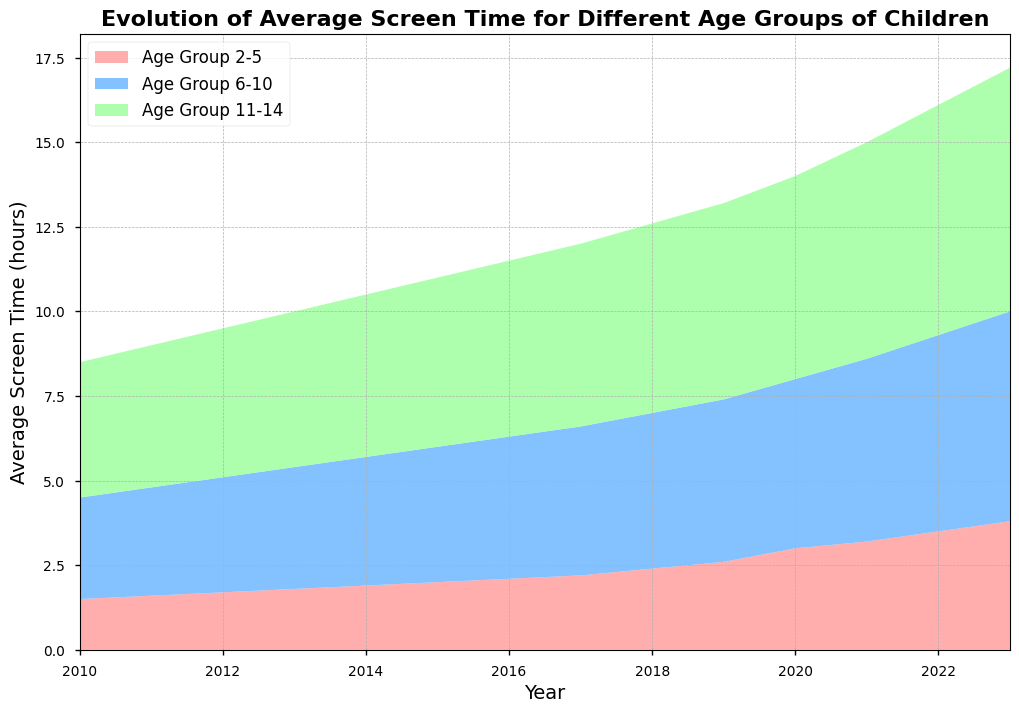What's the trend in average screen time for Age Group 2-5 from 2010 to 2023? By observing the filled area representing Age Group 2-5 over the years, we can see that the screen time generally increases from about 1.5 hours in 2010 to 3.8 hours in 2023.
Answer: Increasing Which age group had the highest average screen time in 2023? By looking at the heights of the stacks in 2023, Age Group 11-14 has the highest average screen time, peaking at 7.2 hours.
Answer: Age Group 11-14 In which year does Age Group 2-5 first exceed 2 hours of average screen time? Checking the plot for when the filled area representing Age Group 2-5 surpasses the 2-hour mark, it first happens in 2015.
Answer: 2015 How much did the average screen time for Age Group 11-14 increase from 2010 to 2023? The average screen time for Age Group 11-14 increased from 4 hours in 2010 to 7.2 hours in 2023. The increase is calculated as 7.2 - 4 = 3.2 hours.
Answer: 3.2 hours Which year shows the most significant increase in average screen time for Age Group 6-10? By comparing the incremental changes between consecutive years, the most significant increase for Age Group 6-10 appears between 2020 (5.0 hours) and 2021 (5.4 hours) with a 0.4-hour increase.
Answer: Between 2020 and 2021 By 2023, what is the total combined average screen time for all age groups? To find the combined average screen time for 2023, sum the values for each age group: 3.8 (Age Group 2-5) + 6.2 (Age Group 6-10) + 7.2 (Age Group 11-14) = 17.2 hours.
Answer: 17.2 hours Which age group has seen the least variation in screen time over the years? Observing the filled areas, Age Group 2-5 shows a relatively steady and gradual increase over the years as compared to the other groups.
Answer: Age Group 2-5 Was there any year where all three age groups had exactly the same increase in average screen time? By checking incremental changes between consecutive years for all three age groups, there’s no year where all three age groups had the exact same increase.
Answer: No Which color represents Age Group 6-10 in the plot? Observing the colors of the stacks, Age Group 6-10 is represented by the blue area.
Answer: Blue 